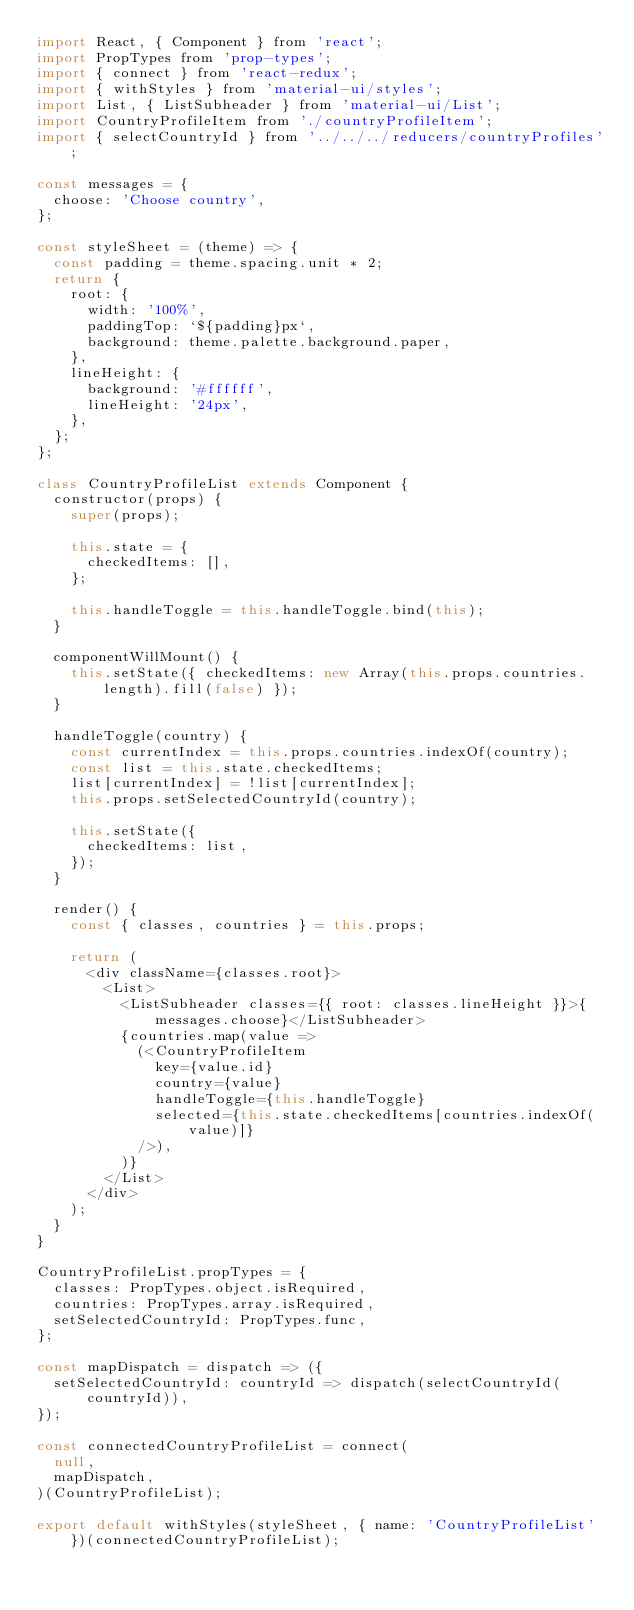<code> <loc_0><loc_0><loc_500><loc_500><_JavaScript_>import React, { Component } from 'react';
import PropTypes from 'prop-types';
import { connect } from 'react-redux';
import { withStyles } from 'material-ui/styles';
import List, { ListSubheader } from 'material-ui/List';
import CountryProfileItem from './countryProfileItem';
import { selectCountryId } from '../../../reducers/countryProfiles';

const messages = {
  choose: 'Choose country',
};

const styleSheet = (theme) => {
  const padding = theme.spacing.unit * 2;
  return {
    root: {
      width: '100%',
      paddingTop: `${padding}px`,
      background: theme.palette.background.paper,
    },
    lineHeight: {
      background: '#ffffff',
      lineHeight: '24px',
    },
  };
};

class CountryProfileList extends Component {
  constructor(props) {
    super(props);

    this.state = {
      checkedItems: [],
    };

    this.handleToggle = this.handleToggle.bind(this);
  }

  componentWillMount() {
    this.setState({ checkedItems: new Array(this.props.countries.length).fill(false) });
  }

  handleToggle(country) {
    const currentIndex = this.props.countries.indexOf(country);
    const list = this.state.checkedItems;
    list[currentIndex] = !list[currentIndex];
    this.props.setSelectedCountryId(country);

    this.setState({
      checkedItems: list,
    });
  }

  render() {
    const { classes, countries } = this.props;

    return (
      <div className={classes.root}>
        <List>
          <ListSubheader classes={{ root: classes.lineHeight }}>{messages.choose}</ListSubheader>
          {countries.map(value =>
            (<CountryProfileItem
              key={value.id}
              country={value}
              handleToggle={this.handleToggle}
              selected={this.state.checkedItems[countries.indexOf(value)]}
            />),
          )}
        </List>
      </div>
    );
  }
}

CountryProfileList.propTypes = {
  classes: PropTypes.object.isRequired,
  countries: PropTypes.array.isRequired,
  setSelectedCountryId: PropTypes.func,
};

const mapDispatch = dispatch => ({
  setSelectedCountryId: countryId => dispatch(selectCountryId(countryId)),
});

const connectedCountryProfileList = connect(
  null,
  mapDispatch,
)(CountryProfileList);

export default withStyles(styleSheet, { name: 'CountryProfileList' })(connectedCountryProfileList);
</code> 